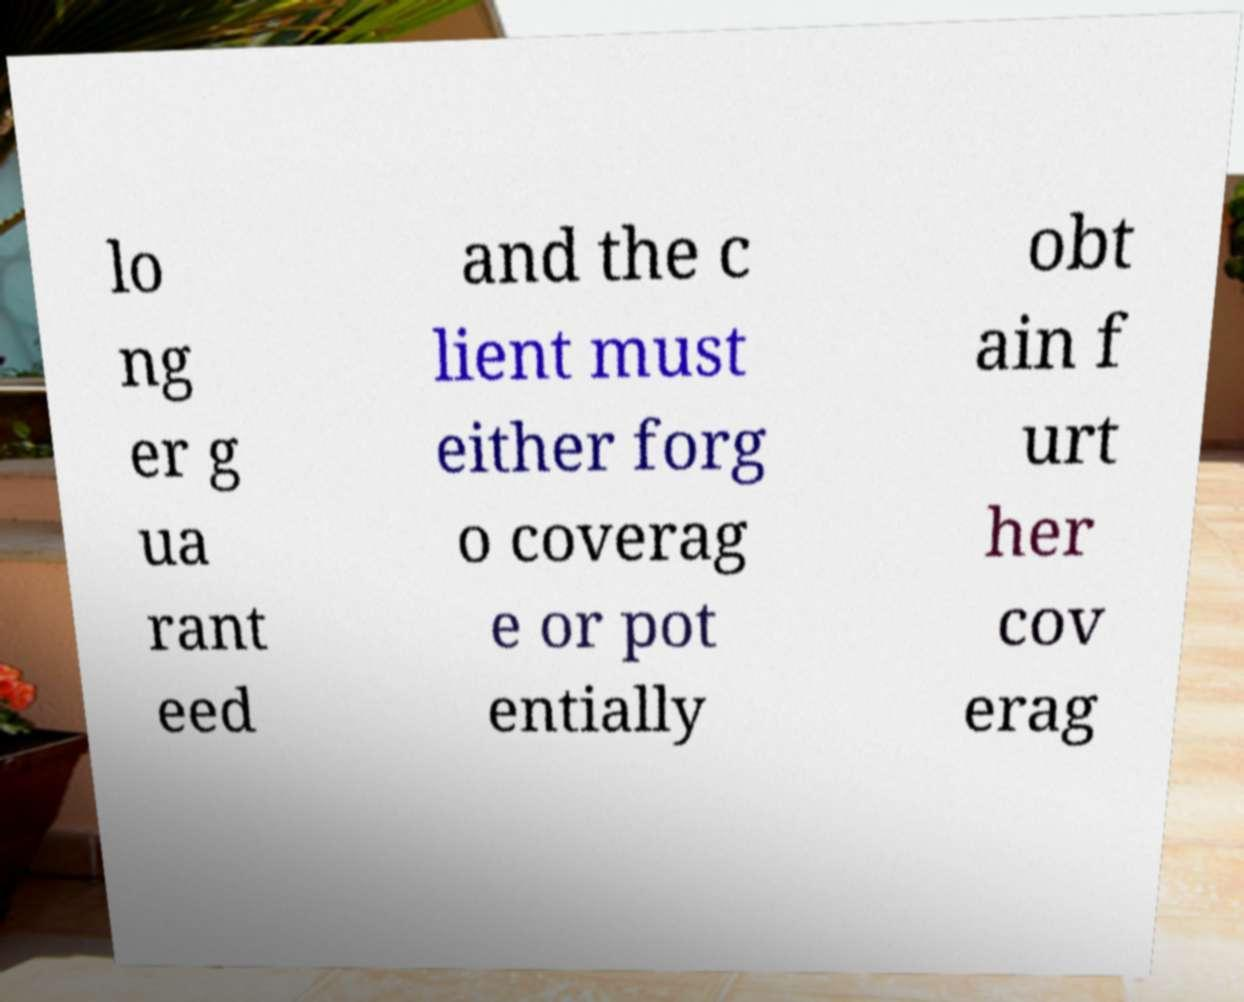For documentation purposes, I need the text within this image transcribed. Could you provide that? lo ng er g ua rant eed and the c lient must either forg o coverag e or pot entially obt ain f urt her cov erag 